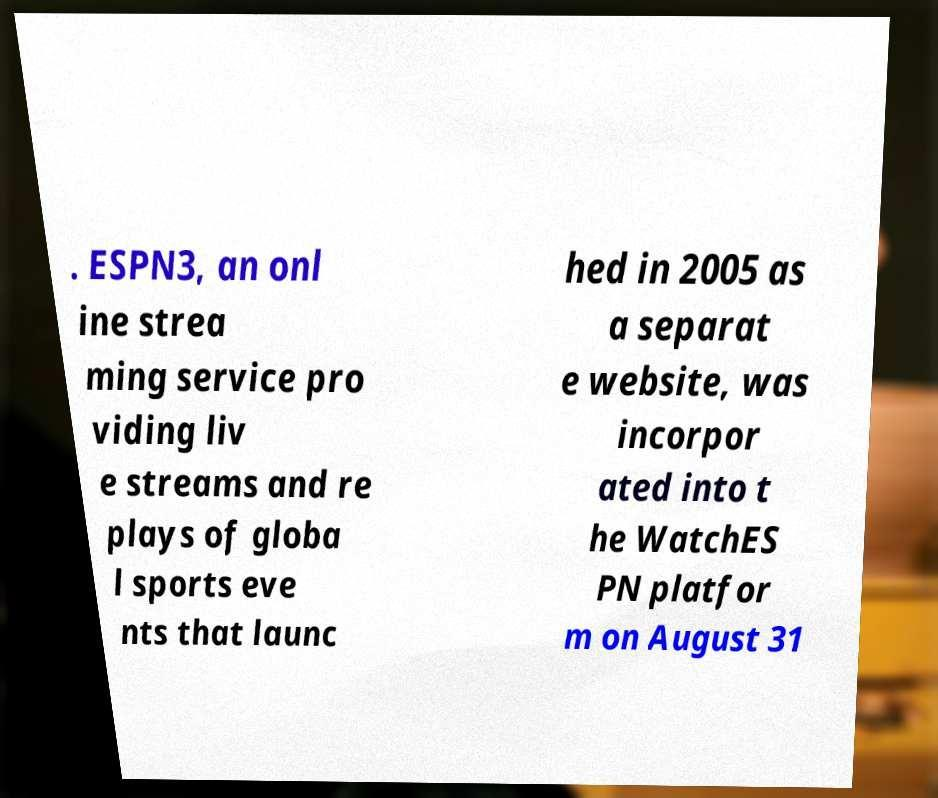For documentation purposes, I need the text within this image transcribed. Could you provide that? . ESPN3, an onl ine strea ming service pro viding liv e streams and re plays of globa l sports eve nts that launc hed in 2005 as a separat e website, was incorpor ated into t he WatchES PN platfor m on August 31 